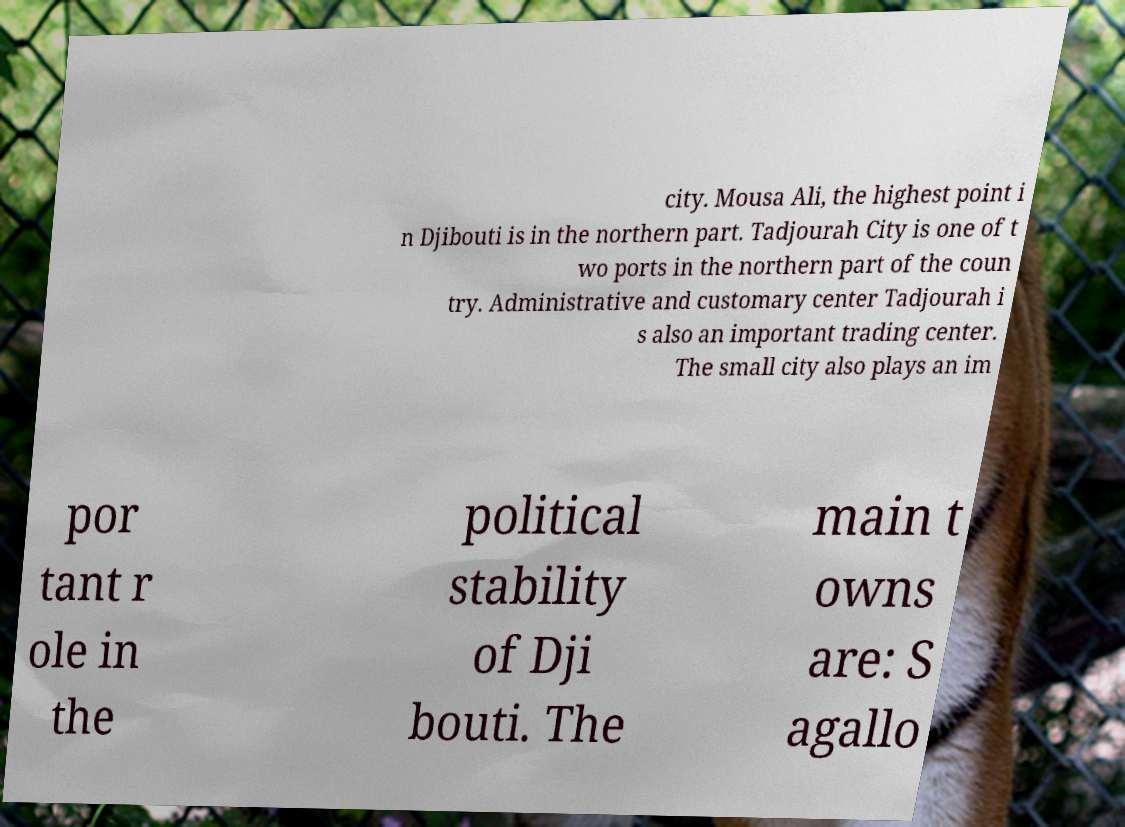Could you assist in decoding the text presented in this image and type it out clearly? city. Mousa Ali, the highest point i n Djibouti is in the northern part. Tadjourah City is one of t wo ports in the northern part of the coun try. Administrative and customary center Tadjourah i s also an important trading center. The small city also plays an im por tant r ole in the political stability of Dji bouti. The main t owns are: S agallo 